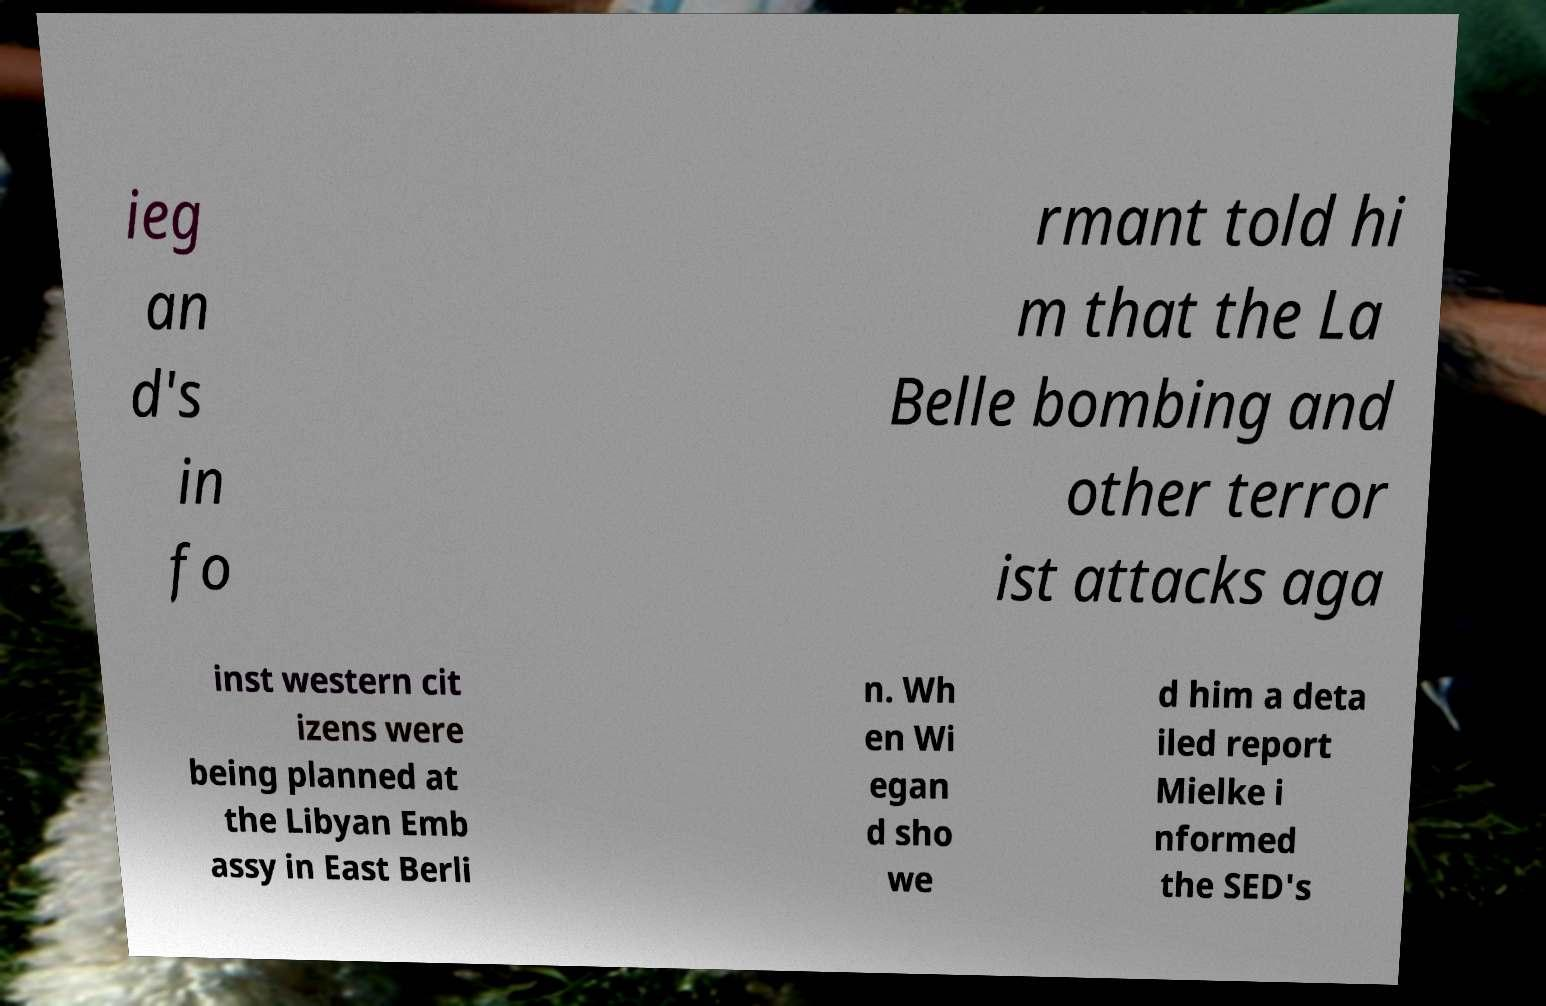Please identify and transcribe the text found in this image. ieg an d's in fo rmant told hi m that the La Belle bombing and other terror ist attacks aga inst western cit izens were being planned at the Libyan Emb assy in East Berli n. Wh en Wi egan d sho we d him a deta iled report Mielke i nformed the SED's 